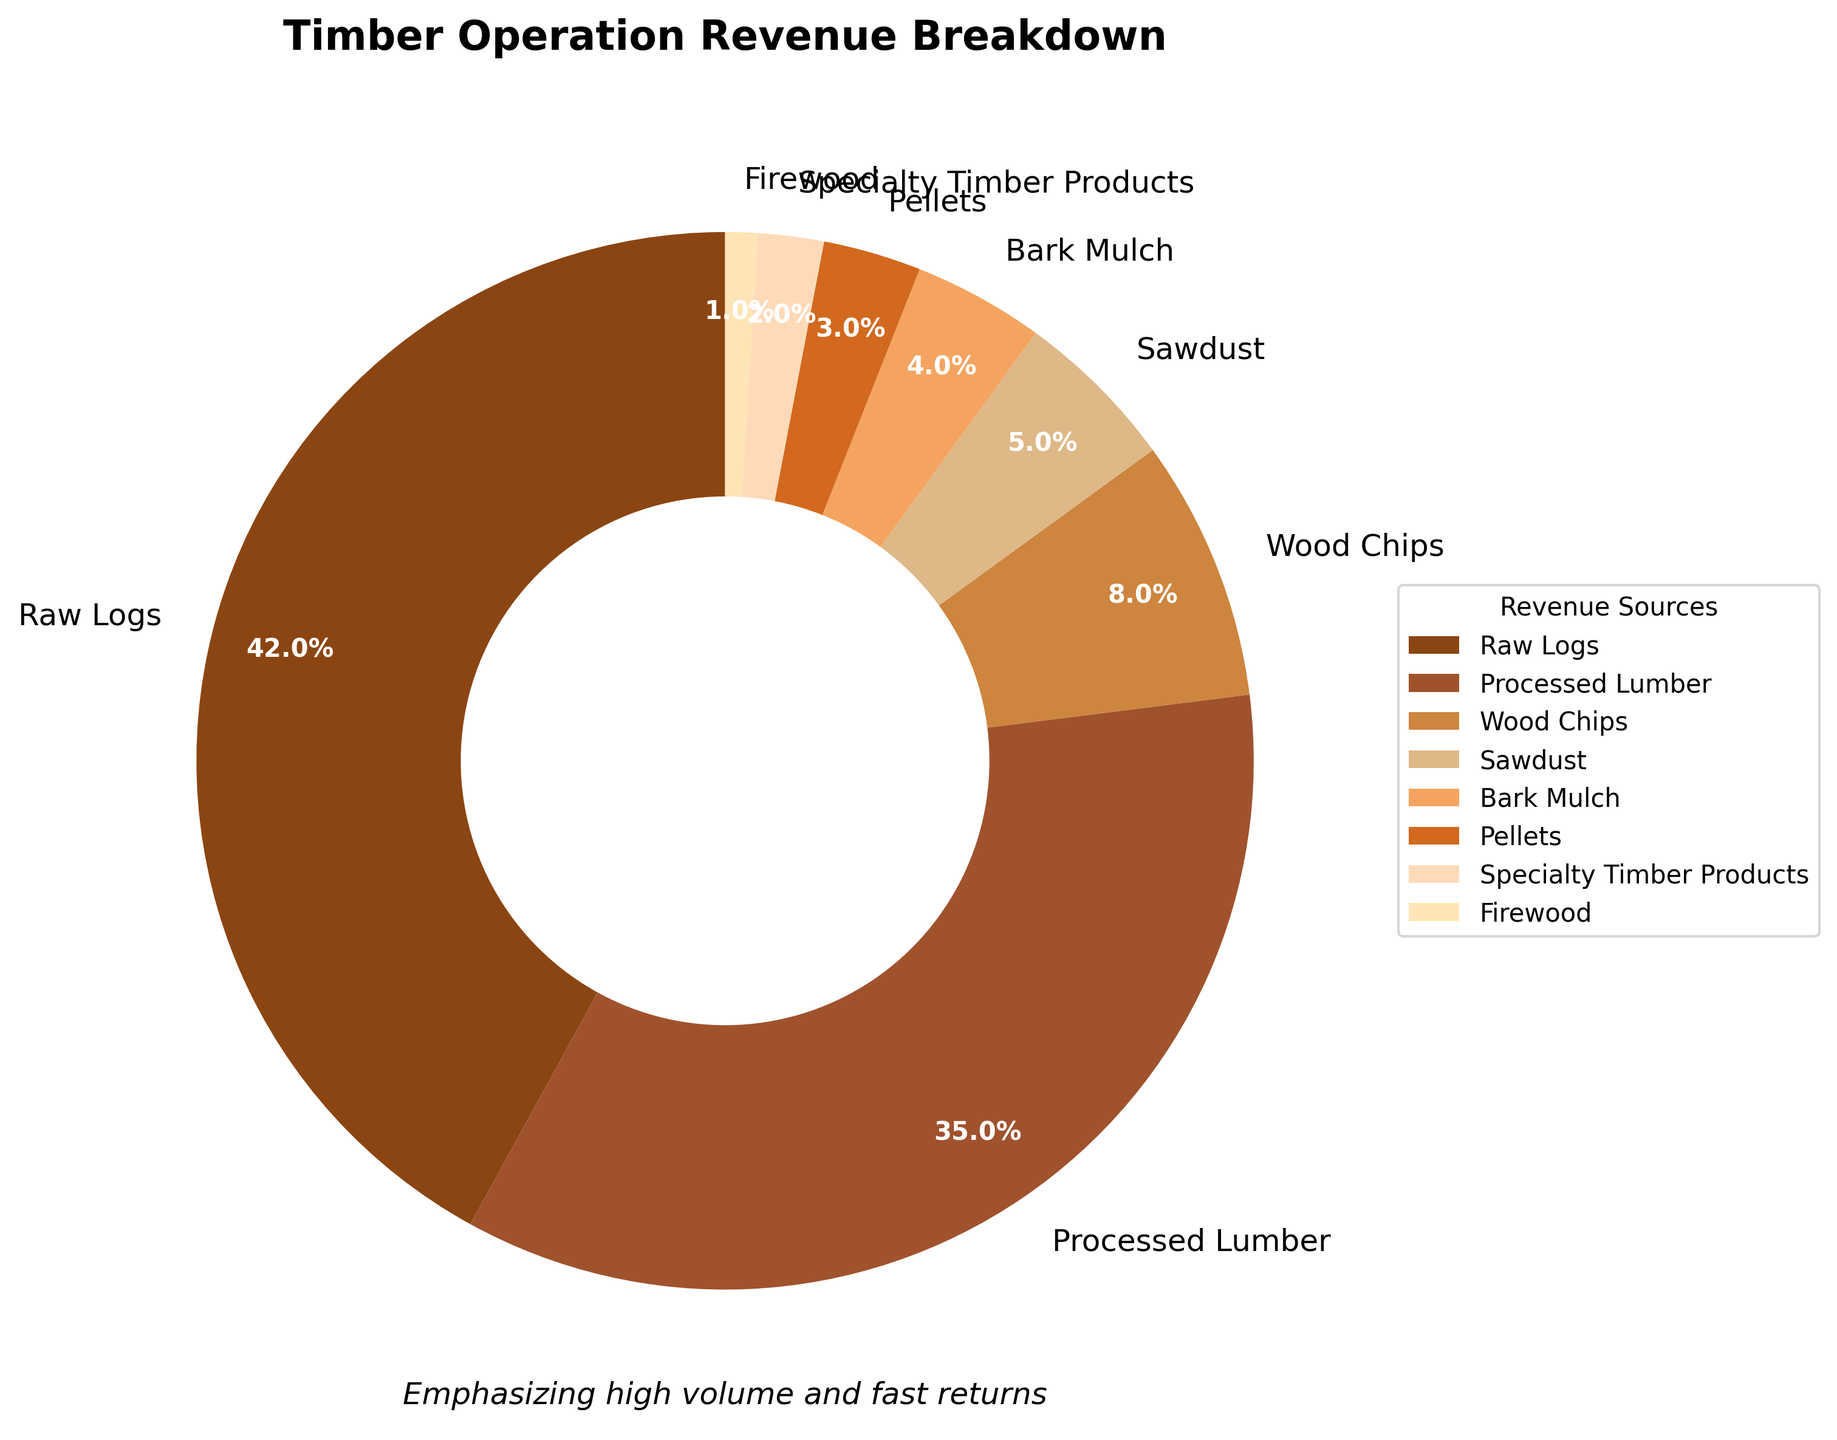Which revenue source contributes the largest percentage? The chart shows that Raw Logs have the largest segment with 42% next to its label.
Answer: Raw Logs What is the combined percentage of Raw Logs and Processed Lumber? Raw Logs contribute 42% and Processed Lumber contributes 35%, summing them up results in 42% + 35% = 77%.
Answer: 77% Which source contributes more, Wood Chips or Sawdust? The chart indicates that Wood Chips contribute 8% and Sawdust contributes 5%. Since 8% is greater than 5%, Wood Chips contributes more.
Answer: Wood Chips Do Wood Chips and Sawdust together account for more or less than Bark Mulch, Pellets, and Firewood combined? Wood Chips (8%) + Sawdust (5%) = 13% while Bark Mulch (4%) + Pellets (3%) + Firewood (1%) = 8%. 13% is greater than 8%, thus they account for more.
Answer: More What is the least contributing revenue source? The chart shows Firewood with the smallest segment and a percentage of 1%, making it the least contributing revenue source.
Answer: Firewood Comparing Specialty Timber Products and Firewood, which has a greater share? Specialty Timber Products contribute 2% while Firewood contributes 1%. Since 2% is greater than 1%, Specialty Timber Products have a greater share.
Answer: Specialty Timber Products What percentage of revenue is generated by sources other than Raw Logs and Processed Lumber? The combined percentage of Raw Logs and Processed Lumber is 77%. The total is 100%, so the remaining sources contribute 100% - 77% = 23%.
Answer: 23% Are Bark Mulch and Pellets combined more than Specialty Timber Products and Firewood combined? Bark Mulch (4%) + Pellets (3%) = 7% and Specialty Timber Products (2%) + Firewood (1%) = 3%. Since 7% is greater than 3%, Bark Mulch and Pellets combined are more.
Answer: Yes Which category has a larger visual segment, Wood Chips or Bark Mulch? The chart shows a larger segment for Wood Chips at 8% compared to Bark Mulch at 4%.
Answer: Wood Chips 